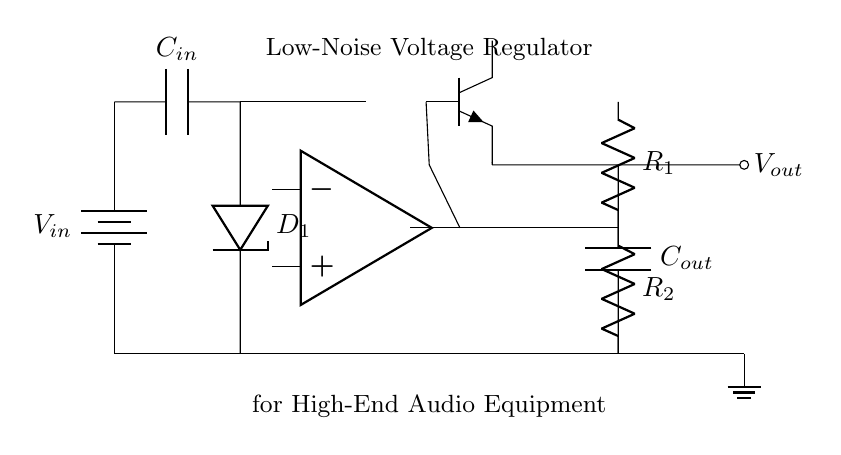What type of regulator is depicted in the circuit? The circuit diagram shows a low-noise voltage regulator, which is indicated in the title of the diagram and is characterized by its specific components designed to minimize output noise.
Answer: low-noise voltage regulator What is the role of the battery in this circuit? The battery provides the input voltage (V in), which is necessary to power the voltage regulator and to ensure that it can step down or filter the voltage to a desired output level.
Answer: input voltage How many resistors are present in the circuit? There are two resistors labeled as R1 and R2 in the feedback network of the circuit, which play a role in regulating the output voltage.
Answer: two What is the output of this voltage regulator? The output is indicated by the node labeled V out, which provides the regulated voltage to the connected circuit or equipment.
Answer: V out What type of capacitor is used at the output of the regulator? The capacitor at the output is labeled C out. It serves to stabilize the output voltage and filter out high-frequency noise, which is critical for high-end audio applications.
Answer: output capacitor Explain how the error amplifier works in this circuit. The error amplifier compares the output voltage to a reference voltage derived from the zener diode. It adjusts the gate voltage of the pass transistor (Q1) to maintain the output voltage at the desired level. This feedback mechanism ensures that any variation in output voltage is corrected, providing stability and minimizing noise.
Answer: feedback mechanism What component is used to reference the voltage in this circuit? A zener diode (D1) is used to establish a stable reference voltage for the feedback network, ensuring that the output voltage remains constant.
Answer: zener diode 